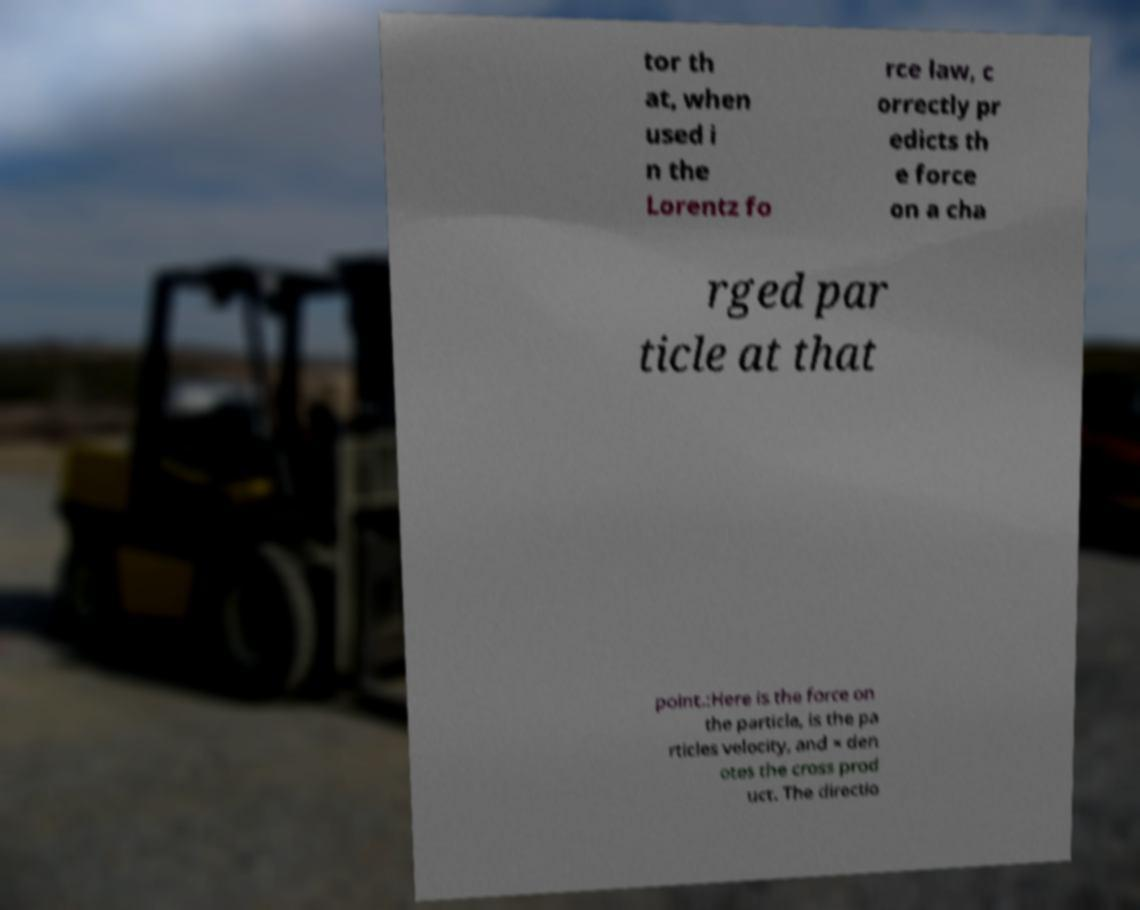For documentation purposes, I need the text within this image transcribed. Could you provide that? tor th at, when used i n the Lorentz fo rce law, c orrectly pr edicts th e force on a cha rged par ticle at that point.:Here is the force on the particle, is the pa rticles velocity, and × den otes the cross prod uct. The directio 